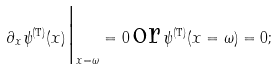Convert formula to latex. <formula><loc_0><loc_0><loc_500><loc_500>\partial _ { x } \psi ^ { ( \text {T} ) } ( x ) \Big | _ { x = \omega } = 0 \, \text {or} \, \psi ^ { ( \text {T} ) } ( x = \omega ) = 0 ;</formula> 